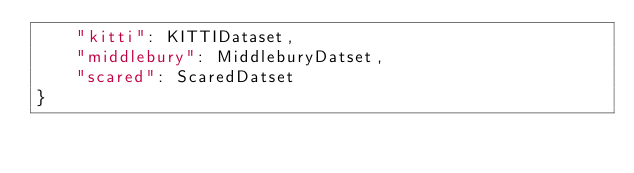<code> <loc_0><loc_0><loc_500><loc_500><_Python_>    "kitti": KITTIDataset,
    "middlebury": MiddleburyDatset,
    "scared": ScaredDatset
}
</code> 